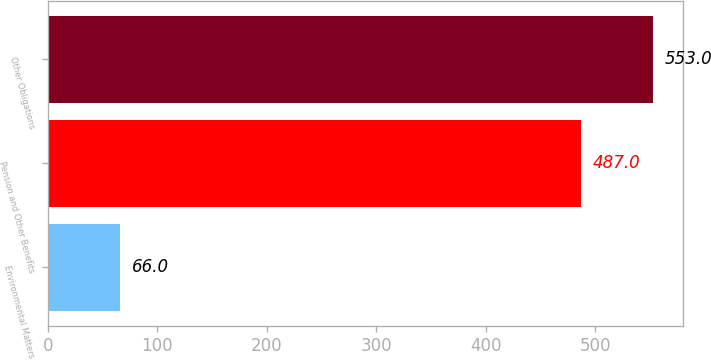Convert chart to OTSL. <chart><loc_0><loc_0><loc_500><loc_500><bar_chart><fcel>Environmental Matters<fcel>Pension and Other Benefits<fcel>Other Obligations<nl><fcel>66<fcel>487<fcel>553<nl></chart> 